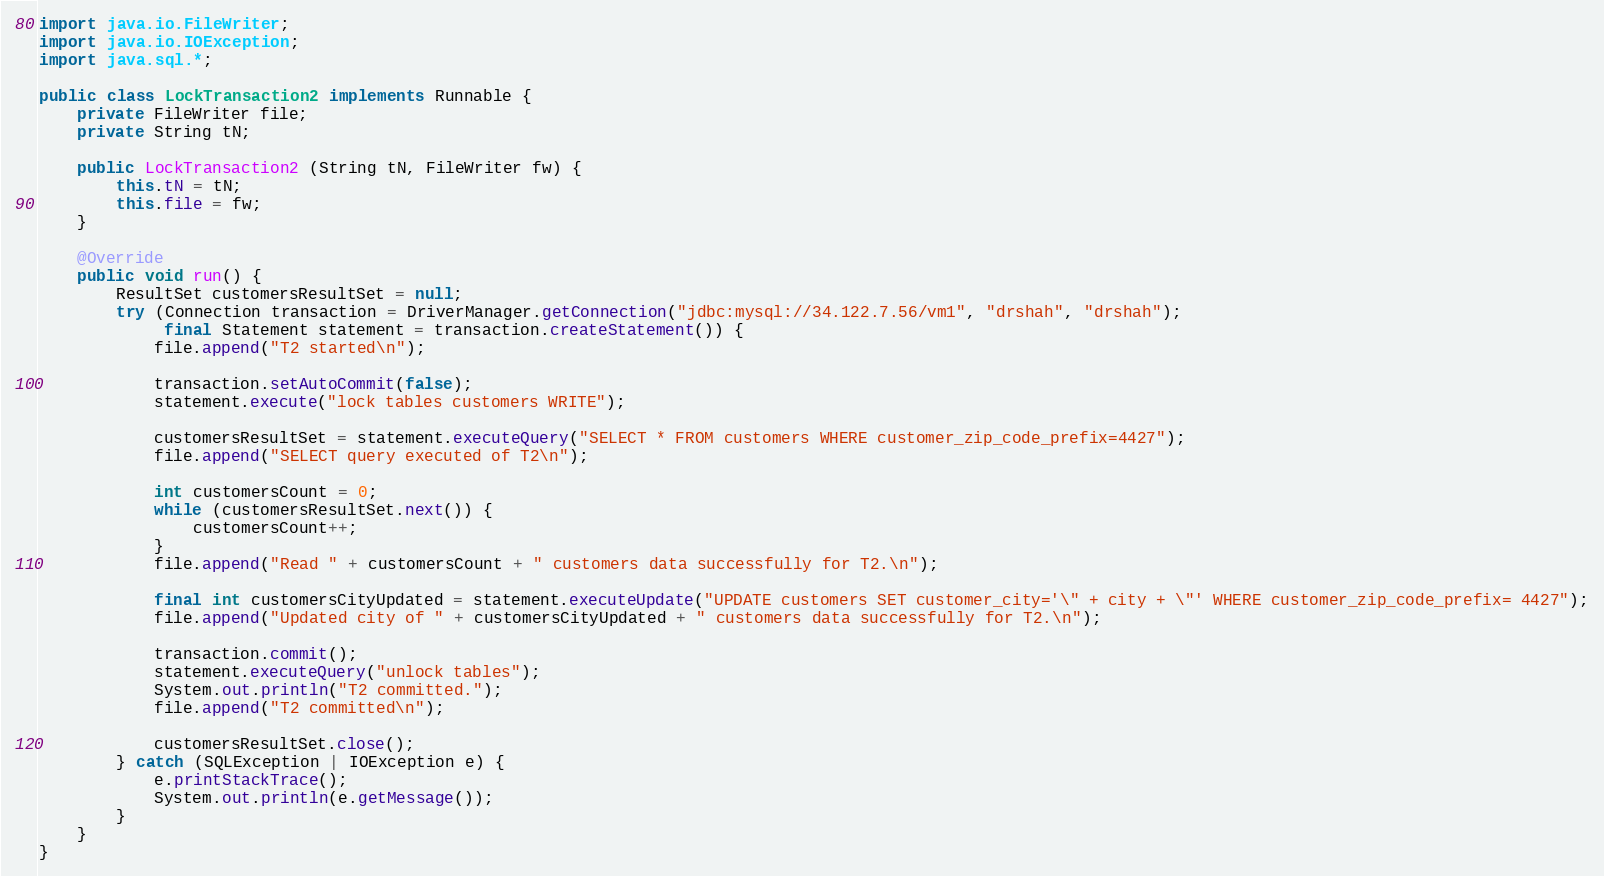<code> <loc_0><loc_0><loc_500><loc_500><_Java_>import java.io.FileWriter;
import java.io.IOException;
import java.sql.*;

public class LockTransaction2 implements Runnable {
    private FileWriter file;
    private String tN;

    public LockTransaction2 (String tN, FileWriter fw) {
        this.tN = tN;
        this.file = fw;
    }

    @Override
    public void run() {
        ResultSet customersResultSet = null;
        try (Connection transaction = DriverManager.getConnection("jdbc:mysql://34.122.7.56/vm1", "drshah", "drshah");
             final Statement statement = transaction.createStatement()) {
            file.append("T2 started\n");

            transaction.setAutoCommit(false);
            statement.execute("lock tables customers WRITE");

            customersResultSet = statement.executeQuery("SELECT * FROM customers WHERE customer_zip_code_prefix=4427");
            file.append("SELECT query executed of T2\n");

            int customersCount = 0;
            while (customersResultSet.next()) {
                customersCount++;
            }
            file.append("Read " + customersCount + " customers data successfully for T2.\n");

            final int customersCityUpdated = statement.executeUpdate("UPDATE customers SET customer_city='\" + city + \"' WHERE customer_zip_code_prefix= 4427");
            file.append("Updated city of " + customersCityUpdated + " customers data successfully for T2.\n");

            transaction.commit();
            statement.executeQuery("unlock tables");
            System.out.println("T2 committed.");
            file.append("T2 committed\n");

            customersResultSet.close();
        } catch (SQLException | IOException e) {
            e.printStackTrace();
            System.out.println(e.getMessage());
        }
    }
}</code> 